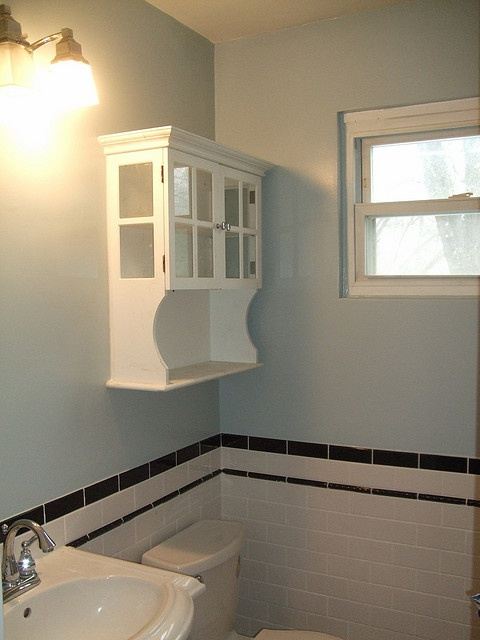Describe the objects in this image and their specific colors. I can see sink in olive, tan, and gray tones and toilet in olive, gray, and tan tones in this image. 